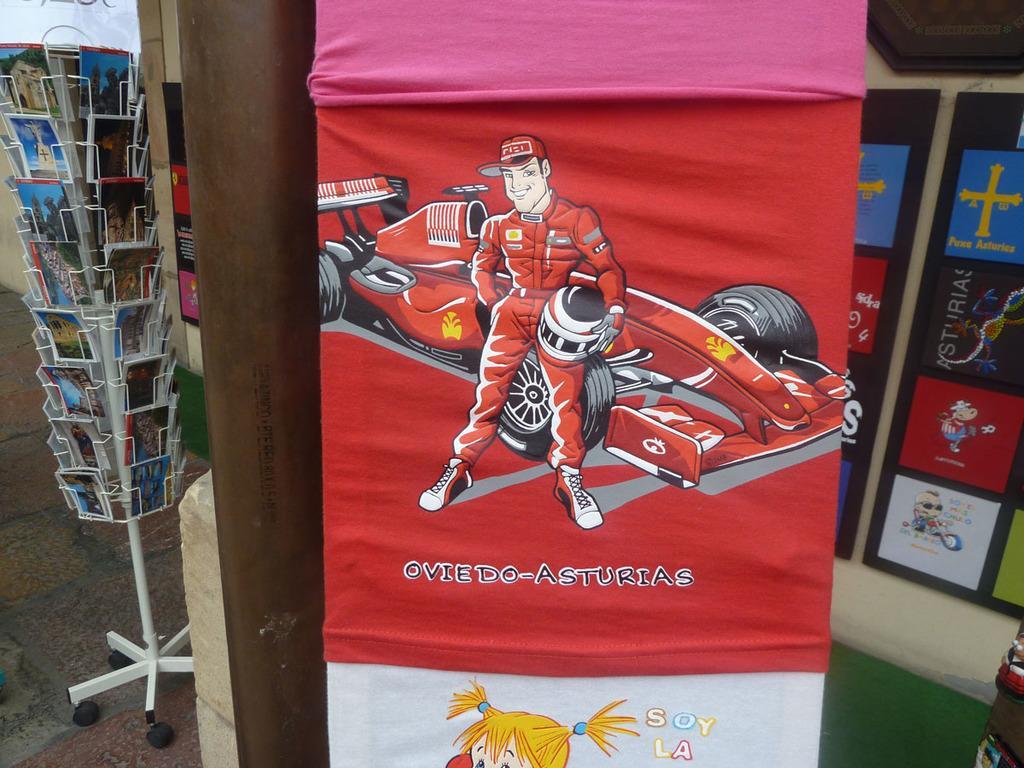How would you summarize this image in a sentence or two? In this picture we can see the clothes which is hanging near to the pipe. On the left we can see many books on the steel racks. On the right we can see the frames on the wall. 